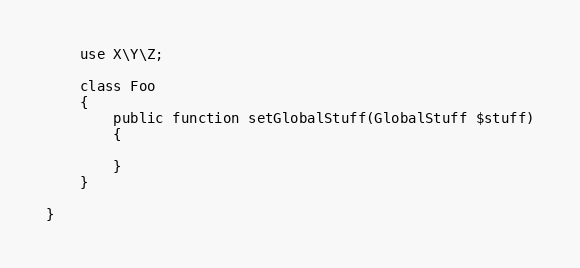<code> <loc_0><loc_0><loc_500><loc_500><_PHP_>
    use X\Y\Z;

    class Foo
    {
        public function setGlobalStuff(GlobalStuff $stuff)
        {

        }
    }

}
</code> 